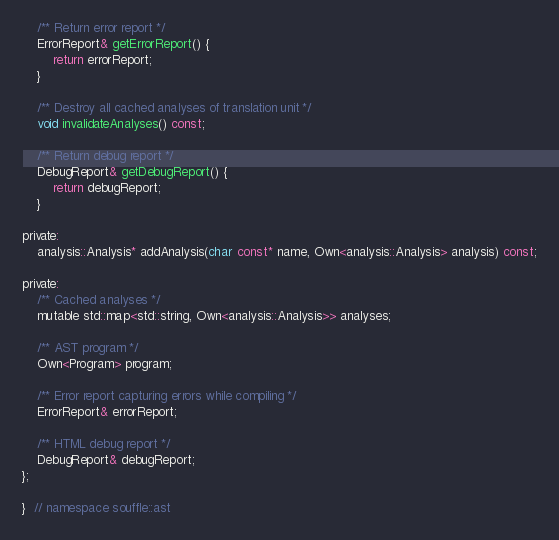Convert code to text. <code><loc_0><loc_0><loc_500><loc_500><_C_>
    /** Return error report */
    ErrorReport& getErrorReport() {
        return errorReport;
    }

    /** Destroy all cached analyses of translation unit */
    void invalidateAnalyses() const;

    /** Return debug report */
    DebugReport& getDebugReport() {
        return debugReport;
    }

private:
    analysis::Analysis* addAnalysis(char const* name, Own<analysis::Analysis> analysis) const;

private:
    /** Cached analyses */
    mutable std::map<std::string, Own<analysis::Analysis>> analyses;

    /** AST program */
    Own<Program> program;

    /** Error report capturing errors while compiling */
    ErrorReport& errorReport;

    /** HTML debug report */
    DebugReport& debugReport;
};

}  // namespace souffle::ast
</code> 